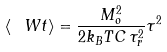<formula> <loc_0><loc_0><loc_500><loc_500>\langle \ W t \rangle = \frac { M _ { o } ^ { 2 } } { 2 k _ { B } T C \, \tau _ { r } ^ { 2 } } \tau ^ { 2 }</formula> 